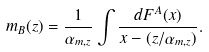Convert formula to latex. <formula><loc_0><loc_0><loc_500><loc_500>m _ { B } ( z ) = \frac { 1 } { \alpha _ { m , z } } \int \frac { d F ^ { A } ( x ) } { x - ( z / \alpha _ { m , z } ) } .</formula> 